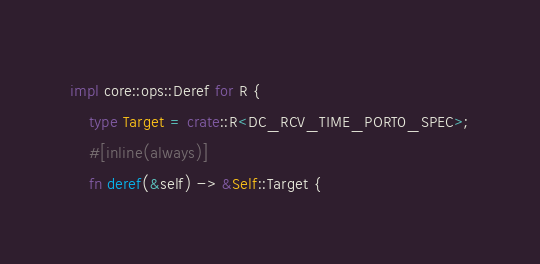<code> <loc_0><loc_0><loc_500><loc_500><_Rust_>impl core::ops::Deref for R {
    type Target = crate::R<DC_RCV_TIME_PORT0_SPEC>;
    #[inline(always)]
    fn deref(&self) -> &Self::Target {</code> 